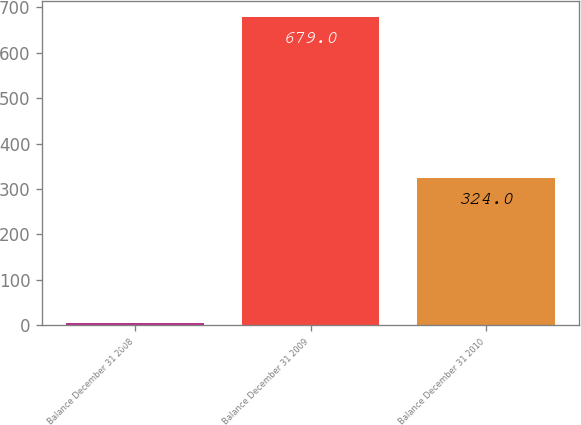Convert chart to OTSL. <chart><loc_0><loc_0><loc_500><loc_500><bar_chart><fcel>Balance December 31 2008<fcel>Balance December 31 2009<fcel>Balance December 31 2010<nl><fcel>4.74<fcel>679<fcel>324<nl></chart> 